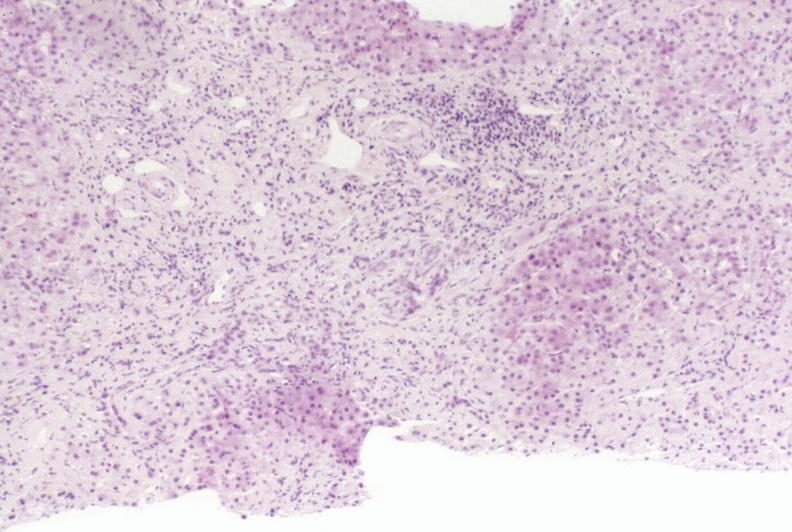does this image show primary sclerosing cholangitis?
Answer the question using a single word or phrase. Yes 